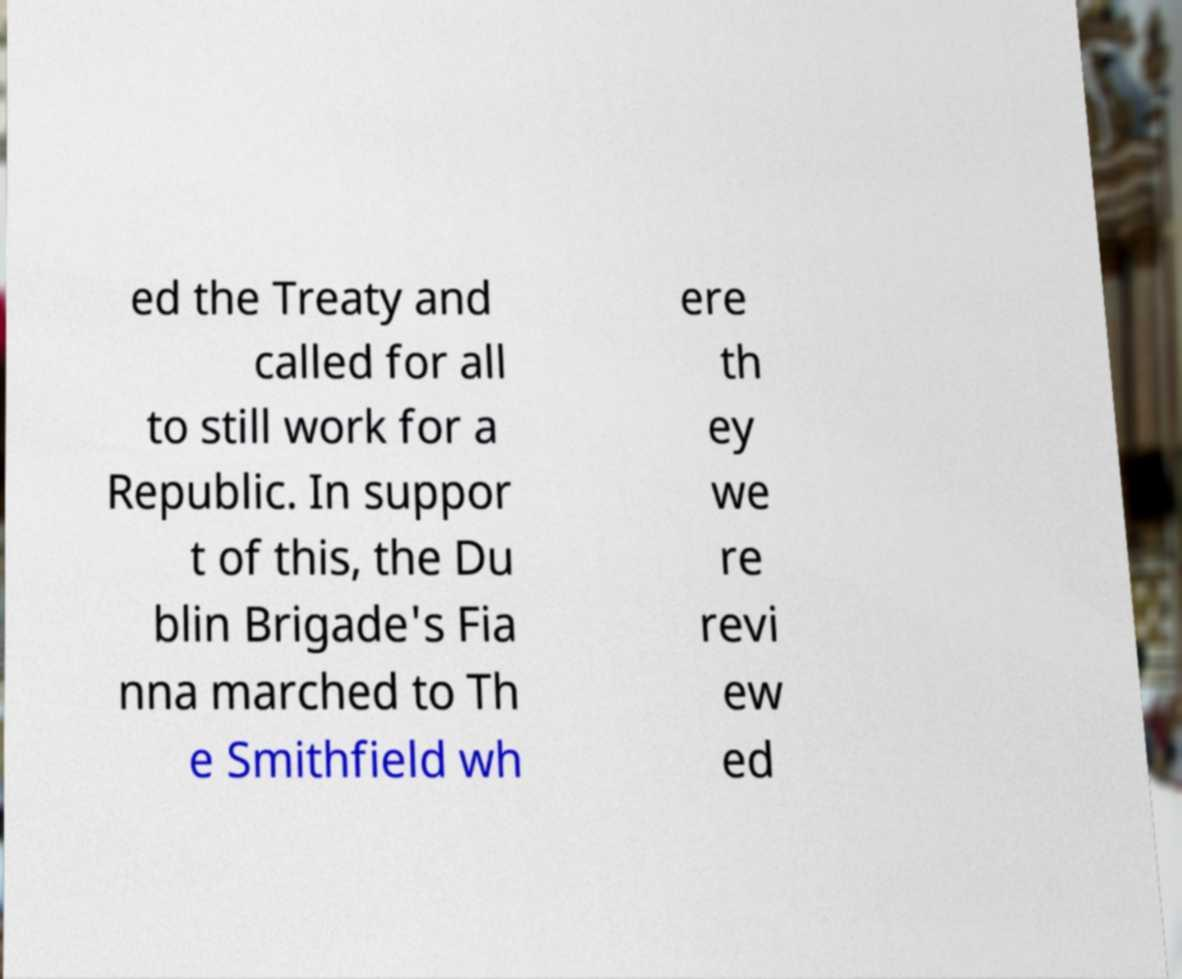Can you accurately transcribe the text from the provided image for me? ed the Treaty and called for all to still work for a Republic. In suppor t of this, the Du blin Brigade's Fia nna marched to Th e Smithfield wh ere th ey we re revi ew ed 